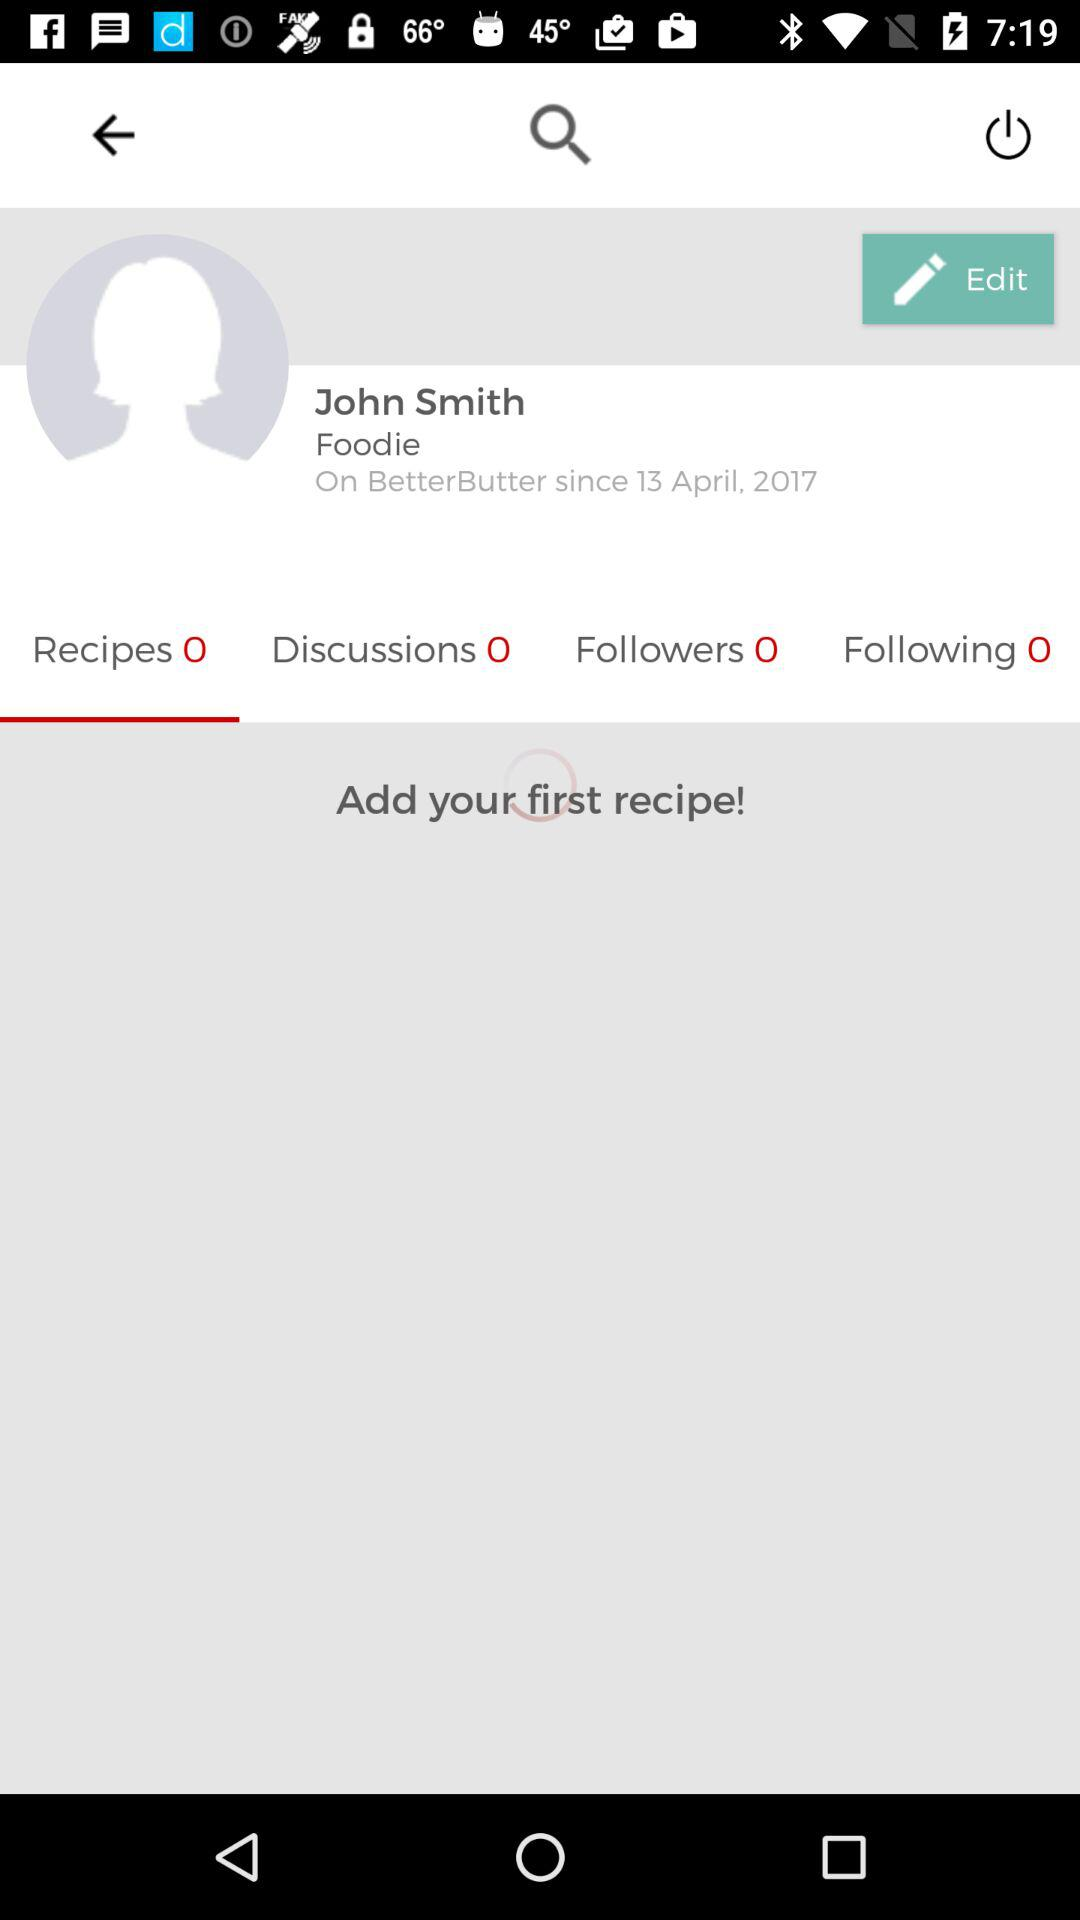How many followers does John Smith have? John Smith has 0 followers. 